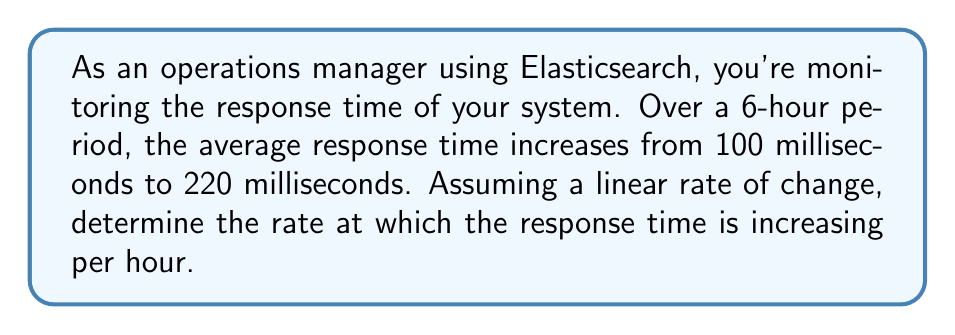Can you solve this math problem? To solve this problem, we'll use the formula for the rate of change:

$$ \text{Rate of Change} = \frac{\text{Change in Y}}{\text{Change in X}} $$

Let's identify our variables:
- Initial response time (Y1) = 100 ms
- Final response time (Y2) = 220 ms
- Time period (X) = 6 hours

1. Calculate the change in response time (ΔY):
   $$ \Delta Y = Y2 - Y1 = 220 \text{ ms} - 100 \text{ ms} = 120 \text{ ms} $$

2. The change in time (ΔX) is already given as 6 hours.

3. Now, let's apply the rate of change formula:
   $$ \text{Rate of Change} = \frac{\Delta Y}{\Delta X} = \frac{120 \text{ ms}}{6 \text{ hours}} = 20 \text{ ms/hour} $$

Therefore, the response time is increasing at a rate of 20 milliseconds per hour.
Answer: 20 ms/hour 